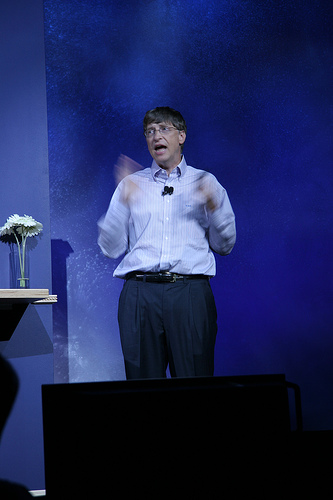<image>
Is there a flowers to the left of the bill gates? Yes. From this viewpoint, the flowers is positioned to the left side relative to the bill gates. 